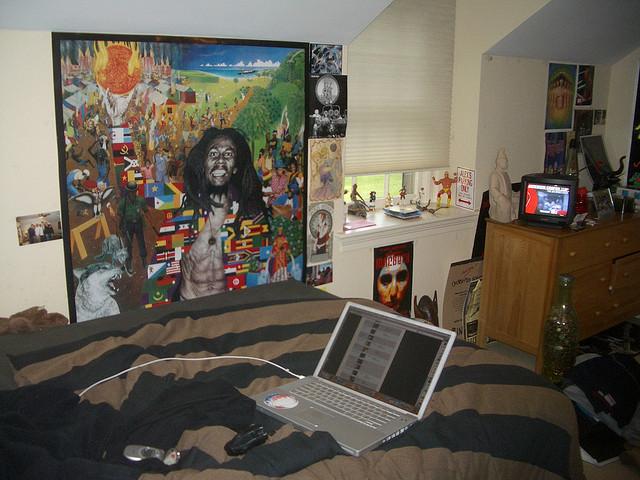Is there a photo of a man?
Answer briefly. Yes. How many cats are in the image?
Answer briefly. 0. Do the posters have frames?
Keep it brief. Yes. Why are the electronics plugged into the wall?
Quick response, please. For power. Where is the telephone located?
Be succinct. Bed. How many laptops are on the bed?
Keep it brief. 1. Are there suitcases?
Answer briefly. No. Who is the character to the far left?
Quick response, please. Bob marley. What musical instrument is shown?
Be succinct. Guitar. Is the computer at its desktop?
Write a very short answer. No. Is this a child's room?
Concise answer only. No. Is the computer depicted an Apple or a PC?
Keep it brief. Apple. Who is on the poster on the wall?
Short answer required. Bob marley. Who is the black man in the middle of the poster?
Keep it brief. Bob marley. What is visible outside the window?
Concise answer only. Grass. What is the black object setting on the bed?
Quick response, please. Phone. What color is the image on the laptop screens?
Be succinct. White and gray. What type of room is this?
Be succinct. Bedroom. Is the monitor on?
Write a very short answer. Yes. What print is on the wallpaper?
Concise answer only. Bob marley. 